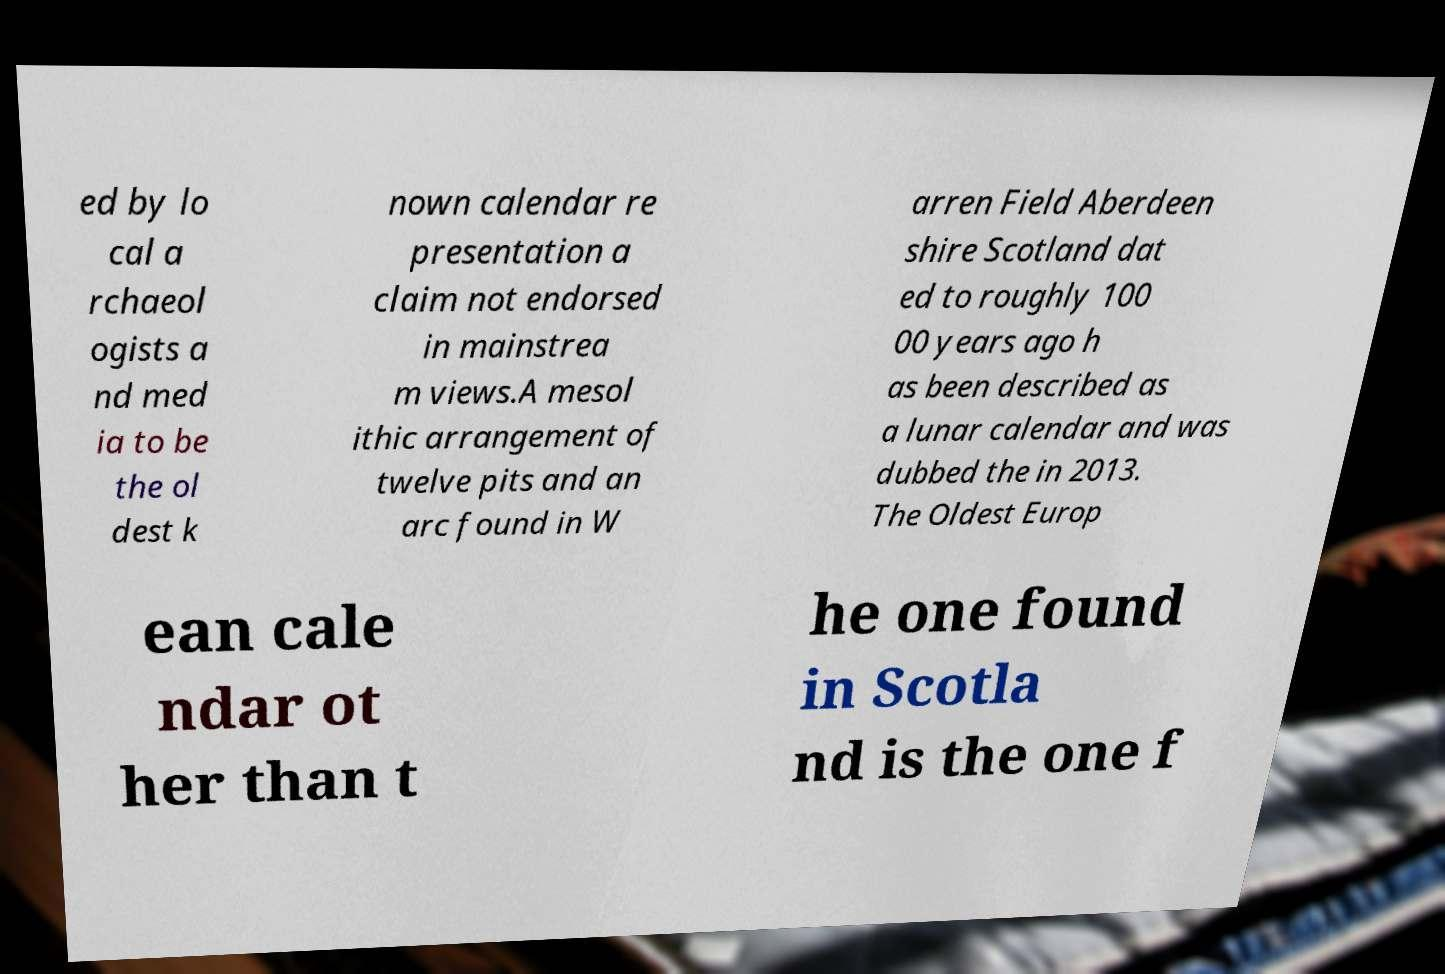What messages or text are displayed in this image? I need them in a readable, typed format. ed by lo cal a rchaeol ogists a nd med ia to be the ol dest k nown calendar re presentation a claim not endorsed in mainstrea m views.A mesol ithic arrangement of twelve pits and an arc found in W arren Field Aberdeen shire Scotland dat ed to roughly 100 00 years ago h as been described as a lunar calendar and was dubbed the in 2013. The Oldest Europ ean cale ndar ot her than t he one found in Scotla nd is the one f 